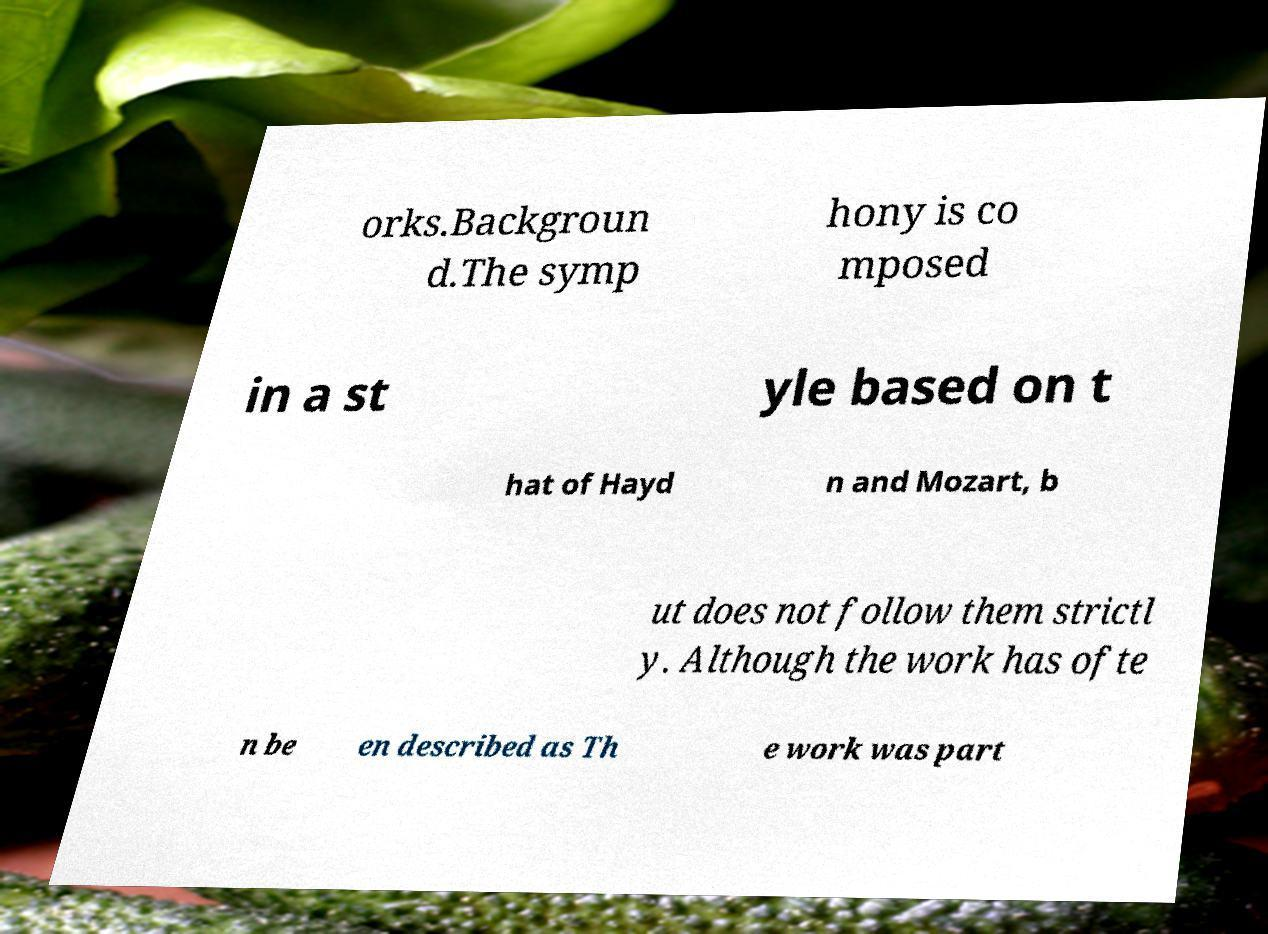For documentation purposes, I need the text within this image transcribed. Could you provide that? orks.Backgroun d.The symp hony is co mposed in a st yle based on t hat of Hayd n and Mozart, b ut does not follow them strictl y. Although the work has ofte n be en described as Th e work was part 